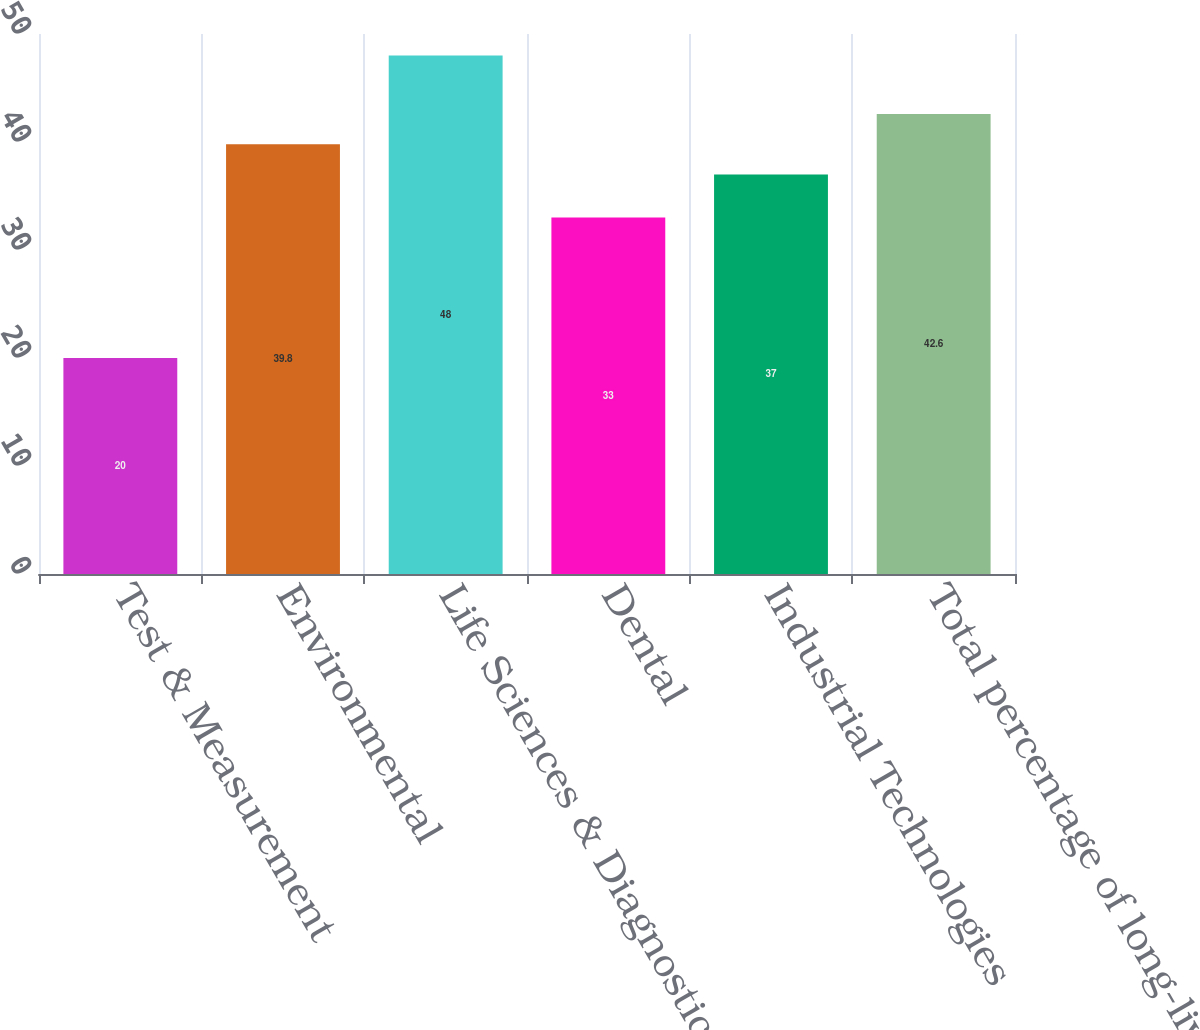Convert chart. <chart><loc_0><loc_0><loc_500><loc_500><bar_chart><fcel>Test & Measurement<fcel>Environmental<fcel>Life Sciences & Diagnostics<fcel>Dental<fcel>Industrial Technologies<fcel>Total percentage of long-lived<nl><fcel>20<fcel>39.8<fcel>48<fcel>33<fcel>37<fcel>42.6<nl></chart> 